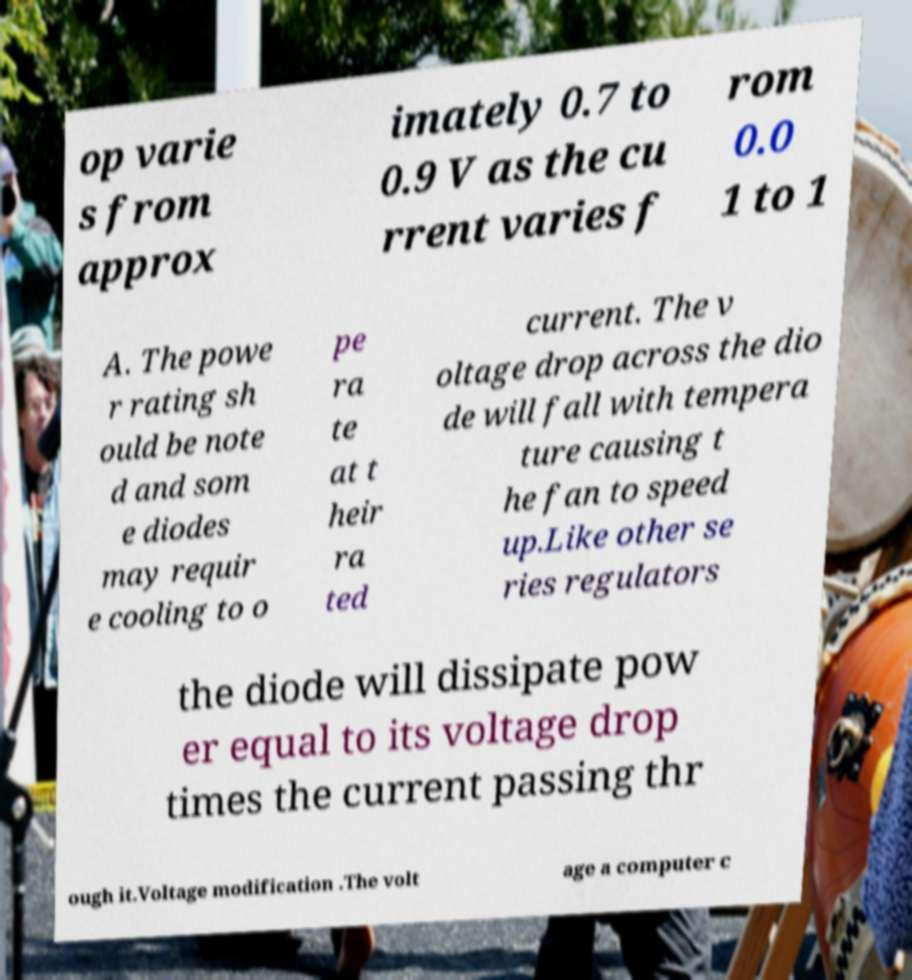For documentation purposes, I need the text within this image transcribed. Could you provide that? op varie s from approx imately 0.7 to 0.9 V as the cu rrent varies f rom 0.0 1 to 1 A. The powe r rating sh ould be note d and som e diodes may requir e cooling to o pe ra te at t heir ra ted current. The v oltage drop across the dio de will fall with tempera ture causing t he fan to speed up.Like other se ries regulators the diode will dissipate pow er equal to its voltage drop times the current passing thr ough it.Voltage modification .The volt age a computer c 